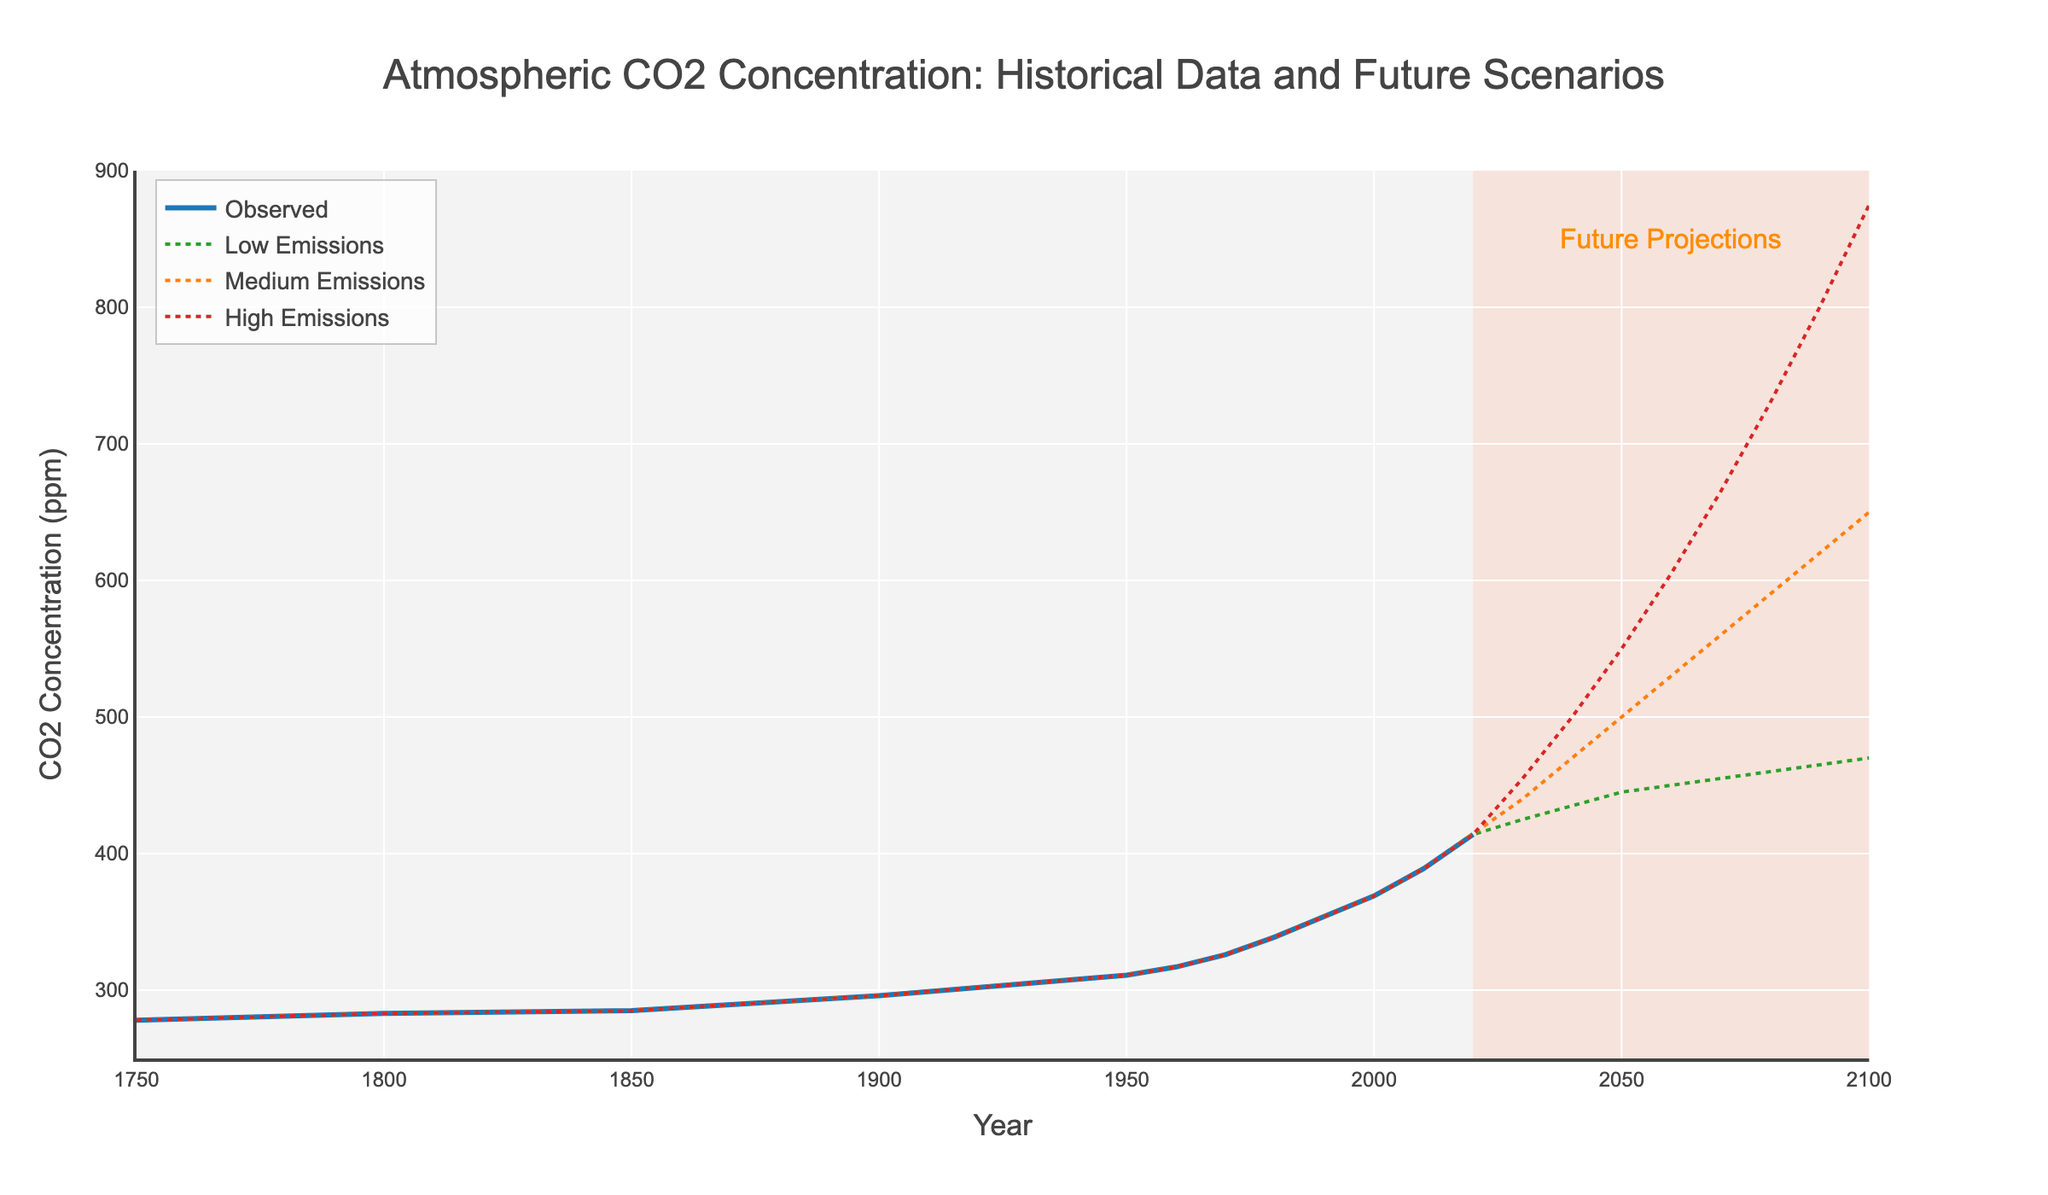What is the observed CO2 concentration in 1950? To find the observed CO2 concentration in 1950, locate the year 1950 on the x-axis and follow it up to the blue line corresponding to the "Observed" label. The value is clearly marked in the data table as well.
Answer: 311 ppm Which emission scenario shows the highest CO2 concentration in 2100 based on the future projections? Examine the different lines representing the "Low Emissions", "Medium Emissions", and "High Emissions" scenarios in 2100. The highest line corresponds to the "High Emissions Scenario," which reaches 875 ppm.
Answer: High Emissions Scenario What is the difference between the CO2 concentration in 1800 and 2020 for the observed data? For the observed CO2 concentration, find the values at 1800 and 2020, which are 283 ppm and 414 ppm respectively. Subtract the smaller value (1800) from the larger value (2020): 414 - 283 = 131 ppm.
Answer: 131 ppm How does the CO2 concentration in 2030 for the Low Emissions Scenario compare to that in 2040 for the Medium Emissions Scenario? Find the CO2 concentration for the Low Emissions Scenario in 2030, which is 425 ppm, and the Medium Emissions Scenario in 2040, which is 470 ppm. Compare the two values: 470 ppm is greater than 425 ppm.
Answer: Medium Emissions Scenario is higher At what year does the Medium Emissions Scenario project CO2 levels to reach approximately 500 ppm? Trace the Medium Emissions Scenario line to around 500 ppm on the y-axis, which corresponds to the year 2050.
Answer: 2050 Describe the visual pattern of the CO2 concentration from 1750 to 2020 for the observed data. From 1750 to approximately 1950, the observed CO2 concentration shows a gradual increase. However, after 1950, it significantly accelerates, forming a steeper upward curve until it reaches 414 ppm by 2020.
Answer: Gradual increase followed by acceleration What is the average projected CO2 concentration in 2100 for all three emission scenarios? First, find the CO2 concentrations for all three scenarios in 2100: Low (470 ppm), Medium (650 ppm), and High (875 ppm). Sum these values and divide by 3 to find the average: (470 + 650 + 875) / 3 = 665 ppm.
Answer: 665 ppm How does the starting value of CO2 concentration in 1750 compare to the projected CO2 concentration in 2050 for the High Emissions Scenario? The starting value in 1750 is 278 ppm. The projected CO2 concentration for the High Emissions Scenario in 2050 is 550 ppm. Since 550 ppm is significantly higher than 278 ppm, we can infer a substantial increase.
Answer: Higher in 2050 for High Emissions Scenario If the observed CO2 concentration increased by the same rate from 2020 to 2100 as from 1980 to 2020, what would be the projected value in 2100? The increase from 1980 (339 ppm) to 2020 (414 ppm) is 414 - 339 = 75 ppm over 40 years. If this rate continues for the next 80 years (2020-2100), the projected increase is (75 / 40) * 80 = 150 ppm. Adding this to 414 ppm gives 414 + 150 = 564 ppm.
Answer: 564 ppm 